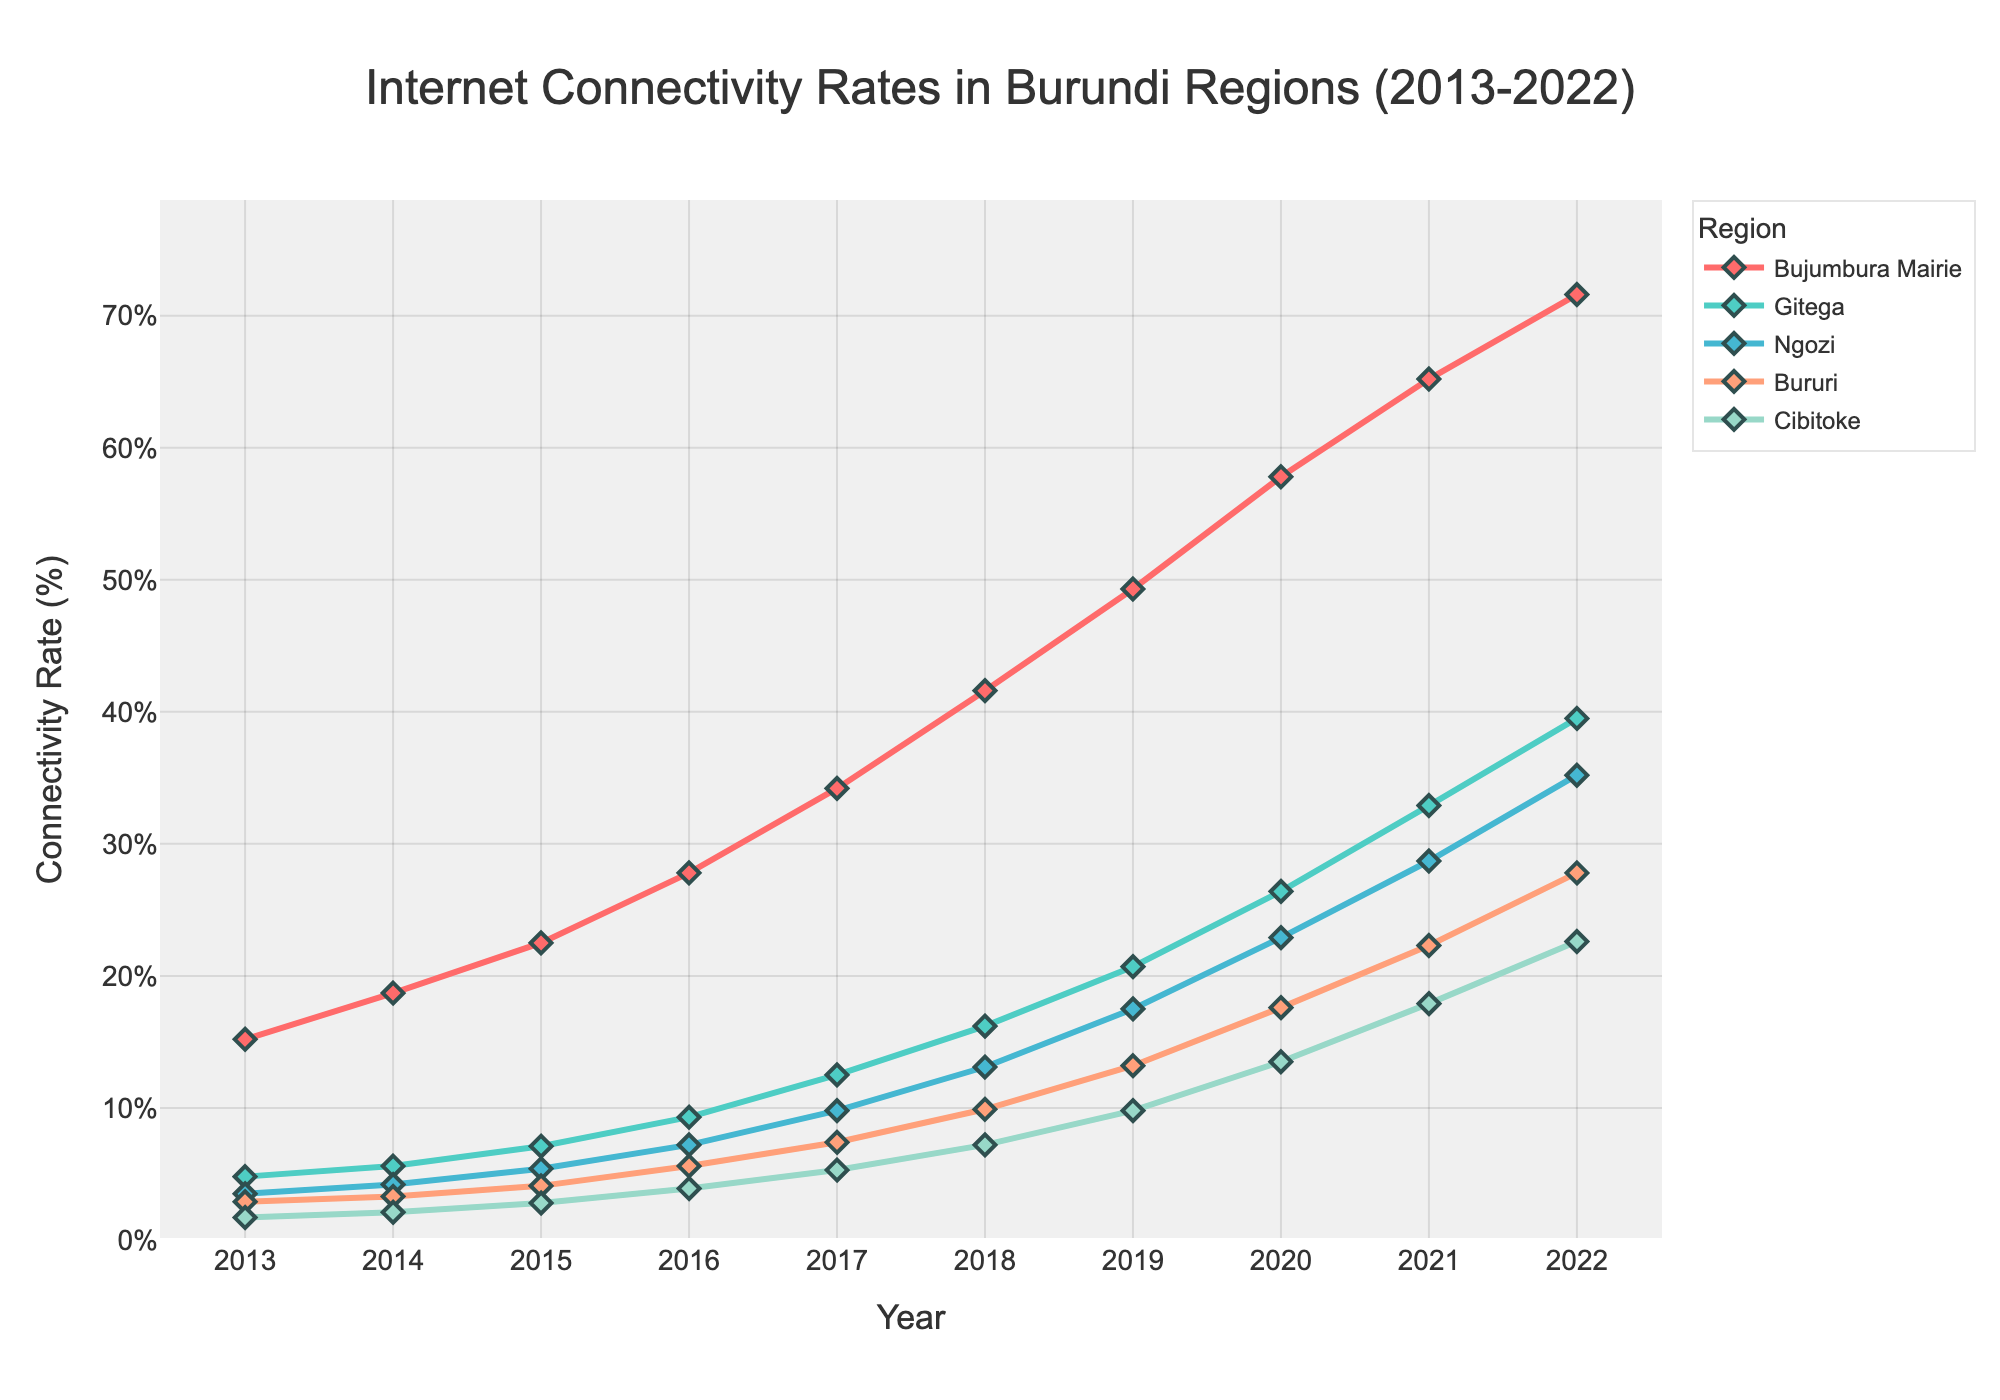Which region had the highest internet connectivity rate in 2022? Look at the year 2022 on the x-axis and observe which line has the highest point. This line is for Bujumbura Mairie.
Answer: Bujumbura Mairie Which region experienced the most significant increase in internet connectivity from 2013 to 2022? Calculate the difference between the 2022 and 2013 values for each region. Bujumbura Mairie increased from 15.2% (2013) to 71.6% (2022), the highest change of 71.6 - 15.2 = 56.4 percentage points.
Answer: Bujumbura Mairie By how much did the connectivity rate in Gitega surpass that of Bururi in 2022? Find the 2022 values for Gitega (39.5%) and Bururi (27.8%), then compute the difference: 39.5 - 27.8 = 11.7 percentage points.
Answer: 11.7% In which year did Ngozi's connectivity rate first exceed 10%? Follow the Ngozi line and identify the year in which it first crosses the 10% threshold. This occurs in 2018 with a connectivity rate of 13.1%.
Answer: 2018 What is the average internet connectivity rate of Cibitoke from 2013 to 2022? Add up the connectivity rates for Cibitoke over the years (1.7, 2.1, 2.8, 3.9, 5.3, 7.2, 9.8, 13.5, 17.9, 22.6) and divide by the number of years (10). (1.7+2.1+2.8+3.9+5.3+7.2+9.8+13.5+17.9+22.6)/10 = 8.68%
Answer: 8.68% Between 2015 and 2016, which region had the most significant percentage point increase in internet connectivity? Calculate the change for each region from 2015 to 2016: Bujumbura Mairie (27.8-22.5 = 5.3%), Gitega (9.3-7.1 = 2.2%), Ngozi (7.2-5.4 = 1.8%), Bururi (5.6-4.1 = 1.5%), Cibitoke (3.9-2.8 = 1.1%). Bujumbura Mairie had the highest increase of 5.3%.
Answer: Bujumbura Mairie What trend can be observed in the internet connectivity rate for all regions from 2013 to 2022? Look at the direction and consistency of the lines for all regions over the years. All regions show an increasing trend in internet connectivity rates.
Answer: Increasing trend Which region had the least connectivity rate in 2013, and what was it? Check the lowest point across all lines in 2013. Cibitoke had the lowest rate with 1.7%.
Answer: Cibitoke, 1.7% How does the connectivity rate in Bururi compare to Ngozi in 2017? Compare the values in 2017 for both Bururi and Ngozi. Bururi is at 7.4%, and Ngozi is at 9.8%.
Answer: Ngozi's rate is higher What is the total increase in connectivity rate for all regions combined from 2013 to 2022? Sum up the increases for each region: Bujumbura Mairie (71.6-15.2), Gitega (39.5-4.8), Ngozi (35.2-3.5), Bururi (27.8-2.9), Cibitoke (22.6-1.7). So: 56.4 + 34.7 + 31.7 + 24.9 + 20.9 = 168.6%.
Answer: 168.6% 